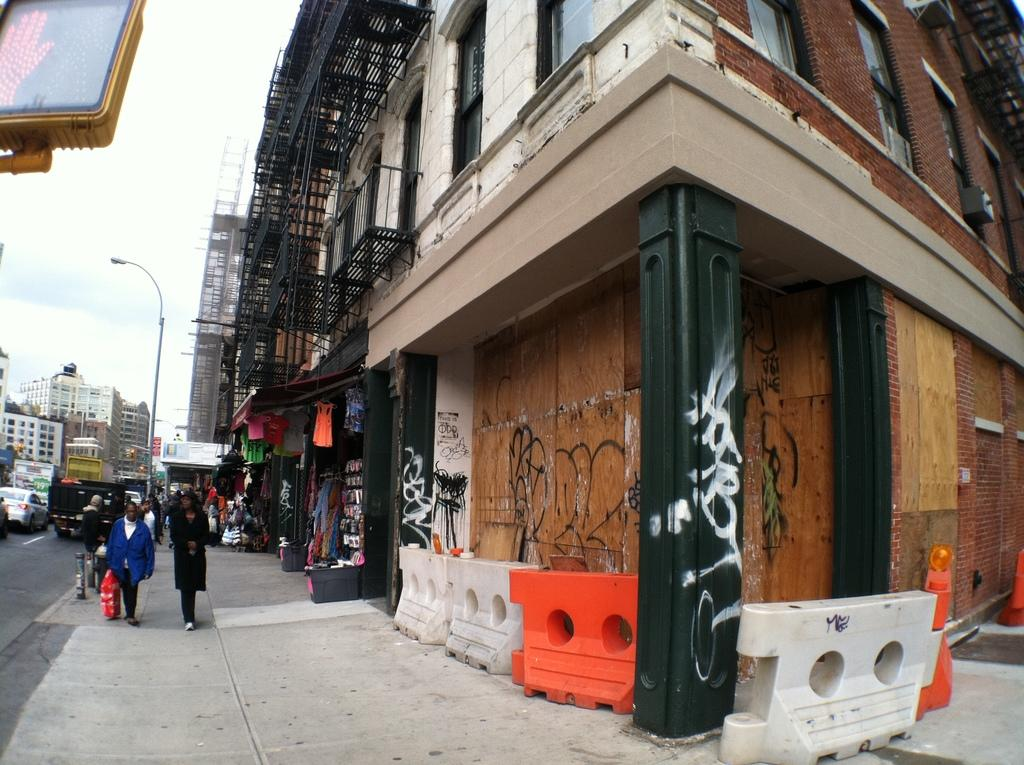What are the people in the image doing? There is a group of people walking in the image. What else can be seen on the road in the image? There are vehicles on the road in the image. What type of structures are present in the image? There are buildings in the image. What are the light poles used for in the image? The light poles are used for providing light in the image. What type of establishments can be seen in the image? There are stores in the image. What is the color of the sky in the image? The sky in the image is white. How does the group of people start combing their hair in the image? There is no group of people combing their hair in the image. 